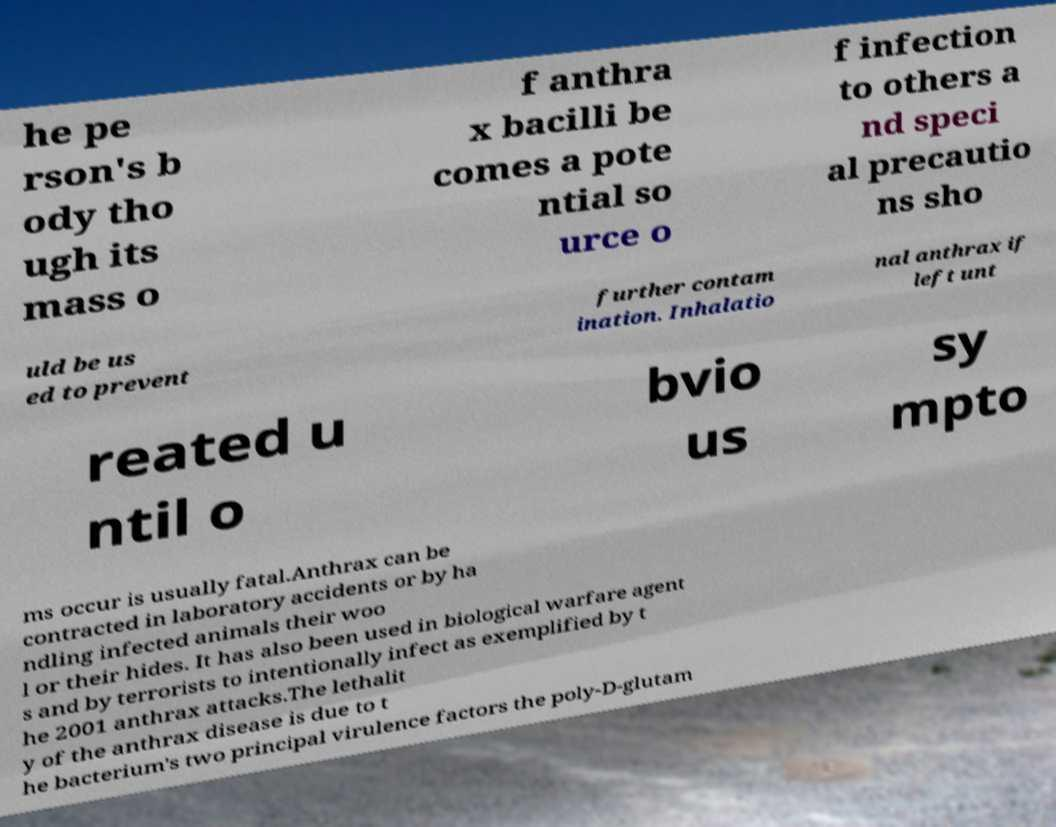What messages or text are displayed in this image? I need them in a readable, typed format. he pe rson's b ody tho ugh its mass o f anthra x bacilli be comes a pote ntial so urce o f infection to others a nd speci al precautio ns sho uld be us ed to prevent further contam ination. Inhalatio nal anthrax if left unt reated u ntil o bvio us sy mpto ms occur is usually fatal.Anthrax can be contracted in laboratory accidents or by ha ndling infected animals their woo l or their hides. It has also been used in biological warfare agent s and by terrorists to intentionally infect as exemplified by t he 2001 anthrax attacks.The lethalit y of the anthrax disease is due to t he bacterium's two principal virulence factors the poly-D-glutam 